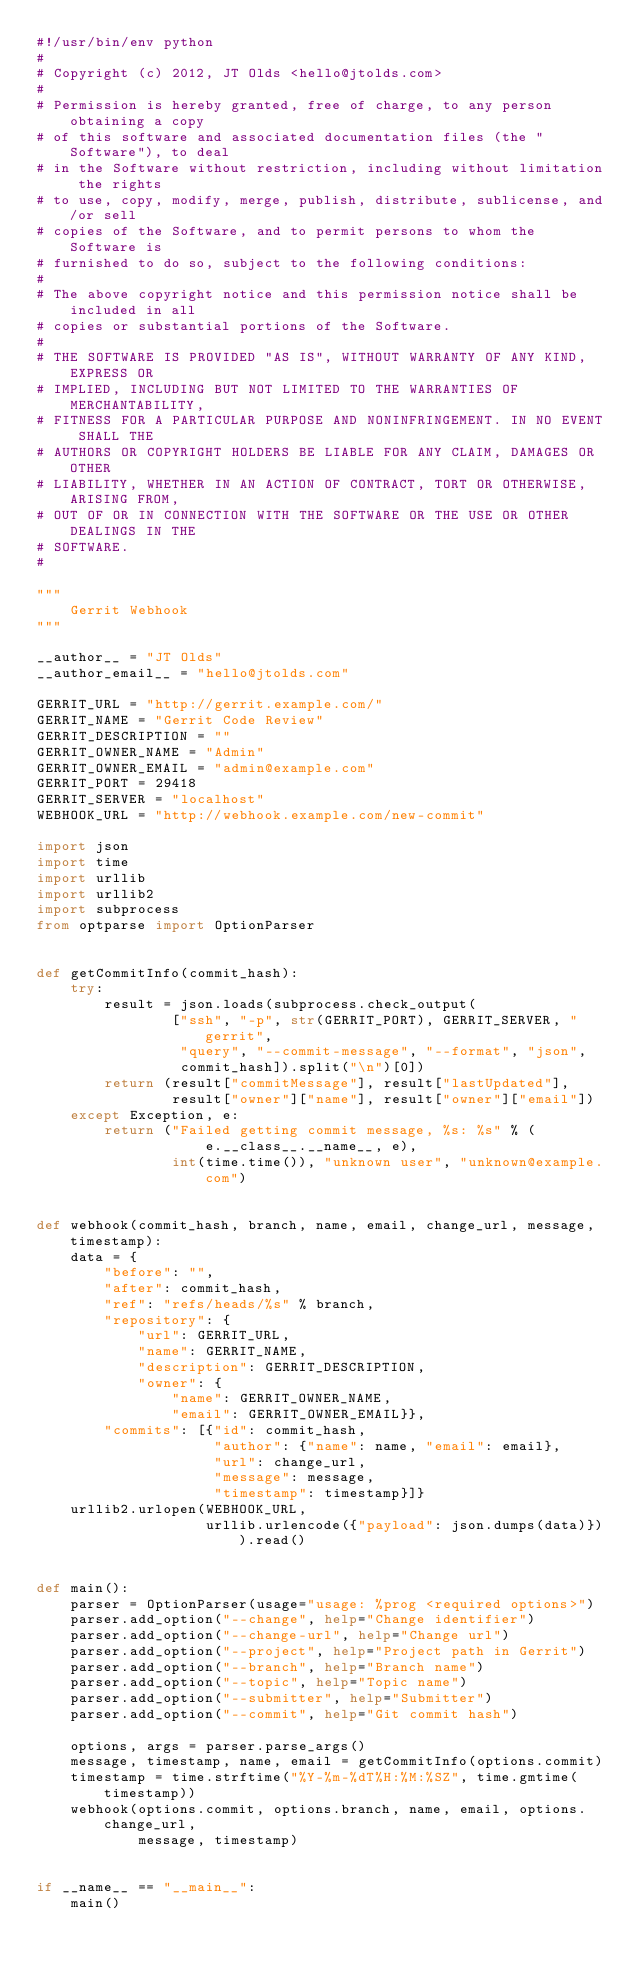Convert code to text. <code><loc_0><loc_0><loc_500><loc_500><_Python_>#!/usr/bin/env python
#
# Copyright (c) 2012, JT Olds <hello@jtolds.com>
#
# Permission is hereby granted, free of charge, to any person obtaining a copy
# of this software and associated documentation files (the "Software"), to deal
# in the Software without restriction, including without limitation the rights
# to use, copy, modify, merge, publish, distribute, sublicense, and/or sell
# copies of the Software, and to permit persons to whom the Software is
# furnished to do so, subject to the following conditions:
#
# The above copyright notice and this permission notice shall be included in all
# copies or substantial portions of the Software.
#
# THE SOFTWARE IS PROVIDED "AS IS", WITHOUT WARRANTY OF ANY KIND, EXPRESS OR
# IMPLIED, INCLUDING BUT NOT LIMITED TO THE WARRANTIES OF MERCHANTABILITY,
# FITNESS FOR A PARTICULAR PURPOSE AND NONINFRINGEMENT. IN NO EVENT SHALL THE
# AUTHORS OR COPYRIGHT HOLDERS BE LIABLE FOR ANY CLAIM, DAMAGES OR OTHER
# LIABILITY, WHETHER IN AN ACTION OF CONTRACT, TORT OR OTHERWISE, ARISING FROM,
# OUT OF OR IN CONNECTION WITH THE SOFTWARE OR THE USE OR OTHER DEALINGS IN THE
# SOFTWARE.
#

"""
    Gerrit Webhook
"""

__author__ = "JT Olds"
__author_email__ = "hello@jtolds.com"

GERRIT_URL = "http://gerrit.example.com/"
GERRIT_NAME = "Gerrit Code Review"
GERRIT_DESCRIPTION = ""
GERRIT_OWNER_NAME = "Admin"
GERRIT_OWNER_EMAIL = "admin@example.com"
GERRIT_PORT = 29418
GERRIT_SERVER = "localhost"
WEBHOOK_URL = "http://webhook.example.com/new-commit"

import json
import time
import urllib
import urllib2
import subprocess
from optparse import OptionParser


def getCommitInfo(commit_hash):
    try:
        result = json.loads(subprocess.check_output(
                ["ssh", "-p", str(GERRIT_PORT), GERRIT_SERVER, "gerrit",
                 "query", "--commit-message", "--format", "json",
                 commit_hash]).split("\n")[0])
        return (result["commitMessage"], result["lastUpdated"],
                result["owner"]["name"], result["owner"]["email"])
    except Exception, e:
        return ("Failed getting commit message, %s: %s" % (
                    e.__class__.__name__, e),
                int(time.time()), "unknown user", "unknown@example.com")


def webhook(commit_hash, branch, name, email, change_url, message, timestamp):
    data = {
        "before": "",
        "after": commit_hash,
        "ref": "refs/heads/%s" % branch,
        "repository": {
            "url": GERRIT_URL,
            "name": GERRIT_NAME,
            "description": GERRIT_DESCRIPTION,
            "owner": {
                "name": GERRIT_OWNER_NAME,
                "email": GERRIT_OWNER_EMAIL}},
        "commits": [{"id": commit_hash,
                     "author": {"name": name, "email": email},
                     "url": change_url,
                     "message": message,
                     "timestamp": timestamp}]}
    urllib2.urlopen(WEBHOOK_URL,
                    urllib.urlencode({"payload": json.dumps(data)})).read()


def main():
    parser = OptionParser(usage="usage: %prog <required options>")
    parser.add_option("--change", help="Change identifier")
    parser.add_option("--change-url", help="Change url")
    parser.add_option("--project", help="Project path in Gerrit")
    parser.add_option("--branch", help="Branch name")
    parser.add_option("--topic", help="Topic name")
    parser.add_option("--submitter", help="Submitter")
    parser.add_option("--commit", help="Git commit hash")

    options, args = parser.parse_args()
    message, timestamp, name, email = getCommitInfo(options.commit)
    timestamp = time.strftime("%Y-%m-%dT%H:%M:%SZ", time.gmtime(timestamp))
    webhook(options.commit, options.branch, name, email, options.change_url,
            message, timestamp)


if __name__ == "__main__":
    main()
</code> 